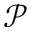<formula> <loc_0><loc_0><loc_500><loc_500>\ m a t h s c r { P }</formula> 